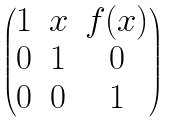Convert formula to latex. <formula><loc_0><loc_0><loc_500><loc_500>\begin{pmatrix} 1 & x & f ( x ) \\ 0 & 1 & 0 \\ 0 & 0 & 1 \end{pmatrix}</formula> 